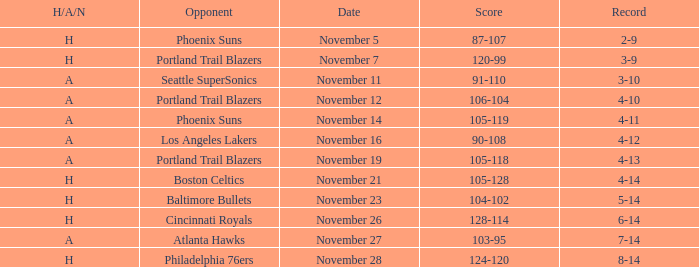On what Date was the Score 105-128? November 21. 